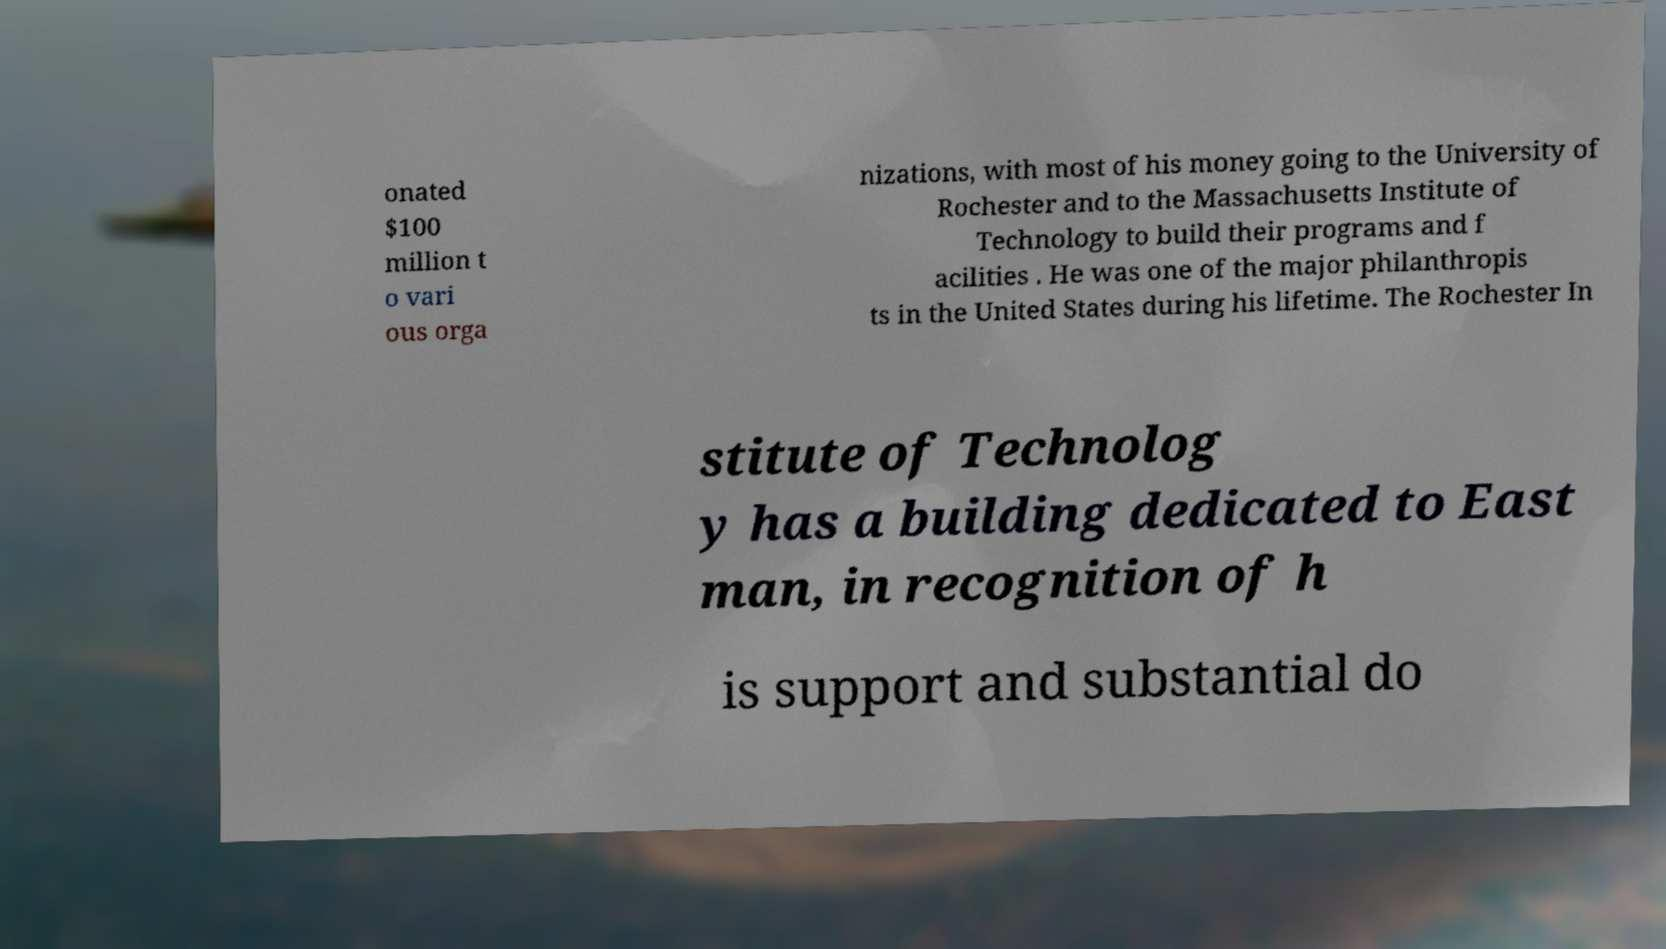Can you accurately transcribe the text from the provided image for me? onated $100 million t o vari ous orga nizations, with most of his money going to the University of Rochester and to the Massachusetts Institute of Technology to build their programs and f acilities . He was one of the major philanthropis ts in the United States during his lifetime. The Rochester In stitute of Technolog y has a building dedicated to East man, in recognition of h is support and substantial do 